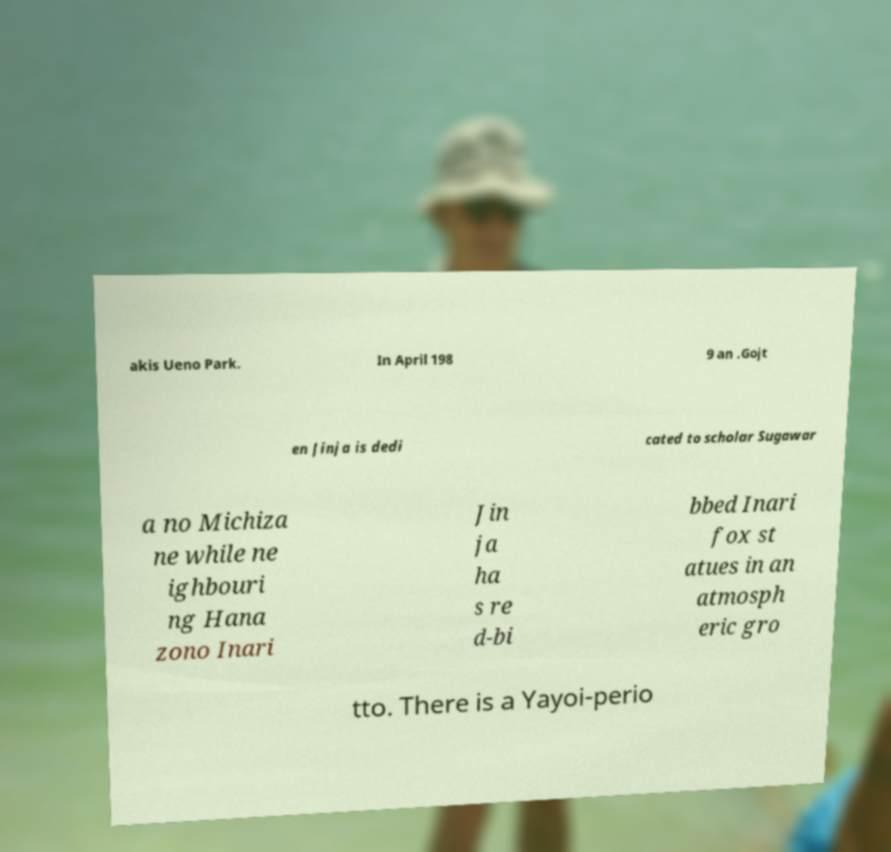For documentation purposes, I need the text within this image transcribed. Could you provide that? akis Ueno Park. In April 198 9 an .Gojt en Jinja is dedi cated to scholar Sugawar a no Michiza ne while ne ighbouri ng Hana zono Inari Jin ja ha s re d-bi bbed Inari fox st atues in an atmosph eric gro tto. There is a Yayoi-perio 